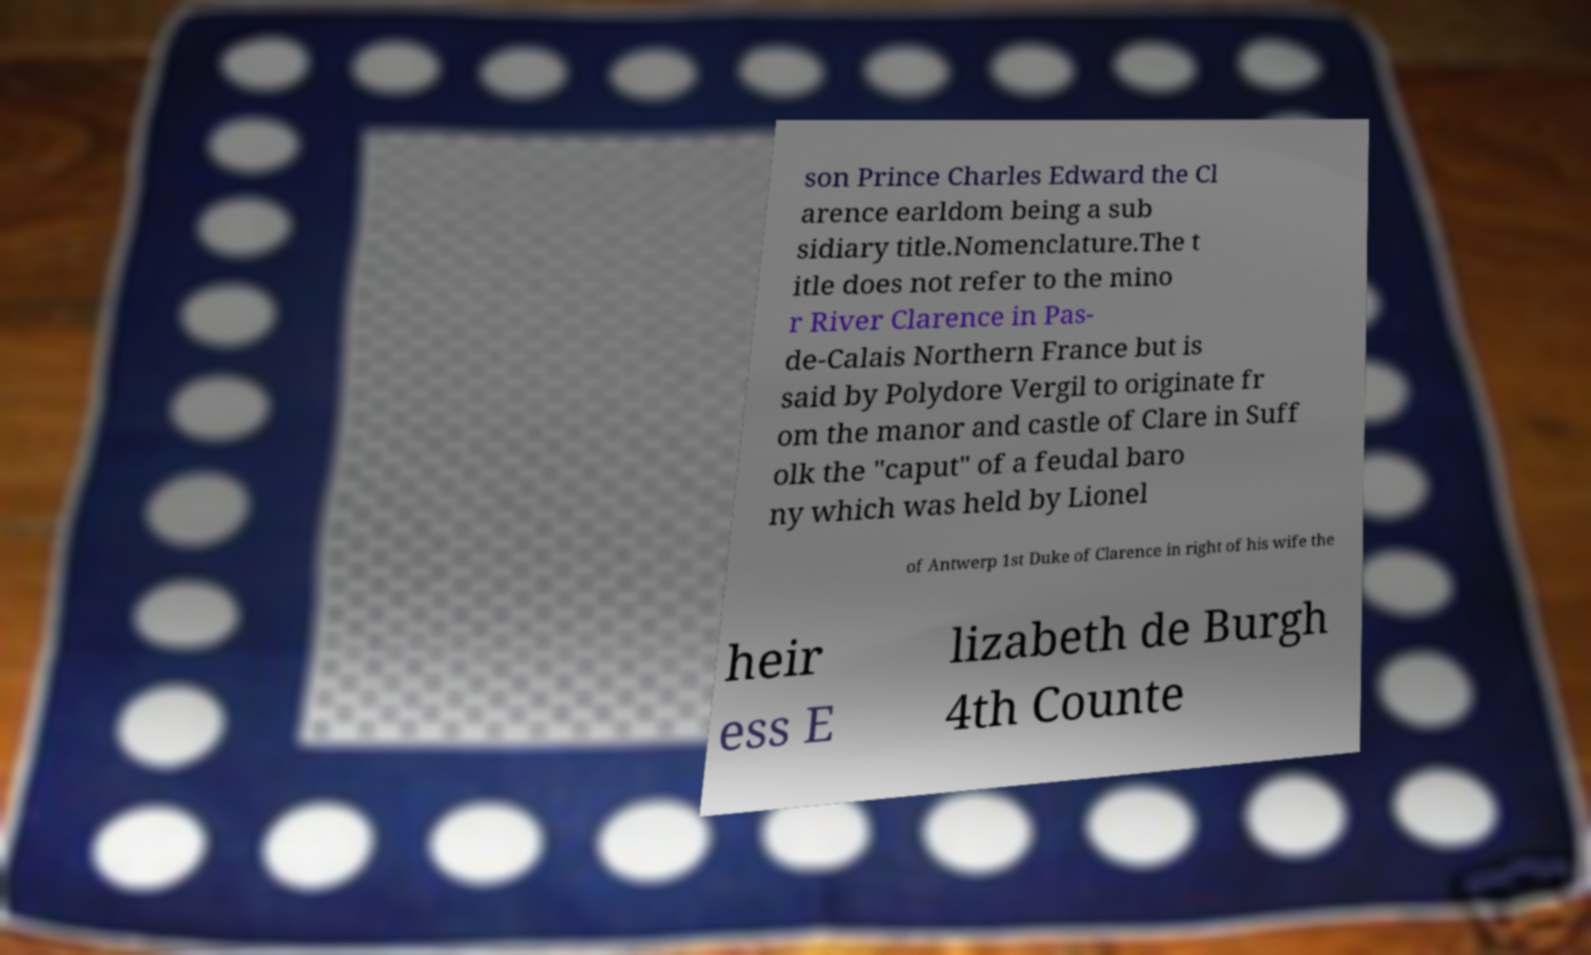Can you read and provide the text displayed in the image?This photo seems to have some interesting text. Can you extract and type it out for me? son Prince Charles Edward the Cl arence earldom being a sub sidiary title.Nomenclature.The t itle does not refer to the mino r River Clarence in Pas- de-Calais Northern France but is said by Polydore Vergil to originate fr om the manor and castle of Clare in Suff olk the "caput" of a feudal baro ny which was held by Lionel of Antwerp 1st Duke of Clarence in right of his wife the heir ess E lizabeth de Burgh 4th Counte 